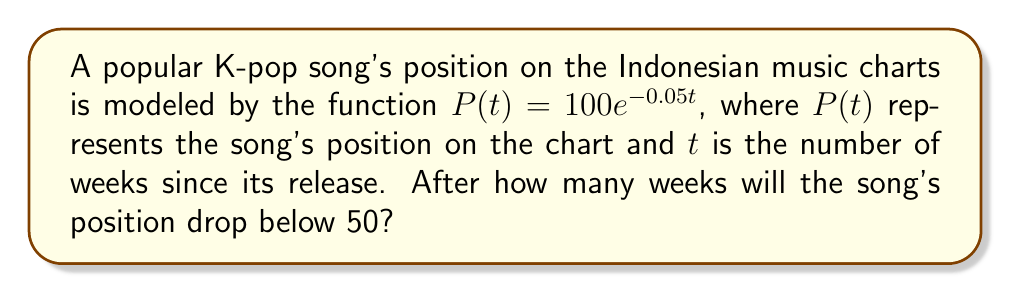Teach me how to tackle this problem. To solve this problem, we need to follow these steps:

1. Set up the equation:
   We want to find $t$ when $P(t) < 50$
   $$100e^{-0.05t} < 50$$

2. Divide both sides by 100:
   $$e^{-0.05t} < 0.5$$

3. Take the natural logarithm of both sides:
   $$\ln(e^{-0.05t}) < \ln(0.5)$$
   $$-0.05t < \ln(0.5)$$

4. Divide both sides by -0.05:
   $$t > \frac{\ln(0.5)}{-0.05}$$

5. Calculate the result:
   $$t > \frac{-0.693147}{-0.05} \approx 13.86$$

Since we're looking for the number of weeks, we need to round up to the next whole number.

Therefore, the song's position will drop below 50 after 14 weeks.
Answer: 14 weeks 